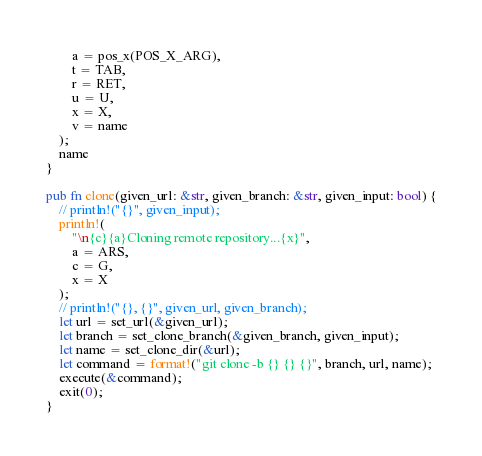Convert code to text. <code><loc_0><loc_0><loc_500><loc_500><_Rust_>        a = pos_x(POS_X_ARG),
        t = TAB,
        r = RET,
        u = U,
        x = X,
        v = name
    );
    name
}

pub fn clone(given_url: &str, given_branch: &str, given_input: bool) {
    // println!("{}", given_input);
    println!(
        "\n{c}{a}Cloning remote repository...{x}",
        a = ARS,
        c = G,
        x = X
    );
    // println!("{}, {}", given_url, given_branch);
    let url = set_url(&given_url);
    let branch = set_clone_branch(&given_branch, given_input);
    let name = set_clone_dir(&url);
    let command = format!("git clone -b {} {} {}", branch, url, name);
    execute(&command);
    exit(0);
}
</code> 